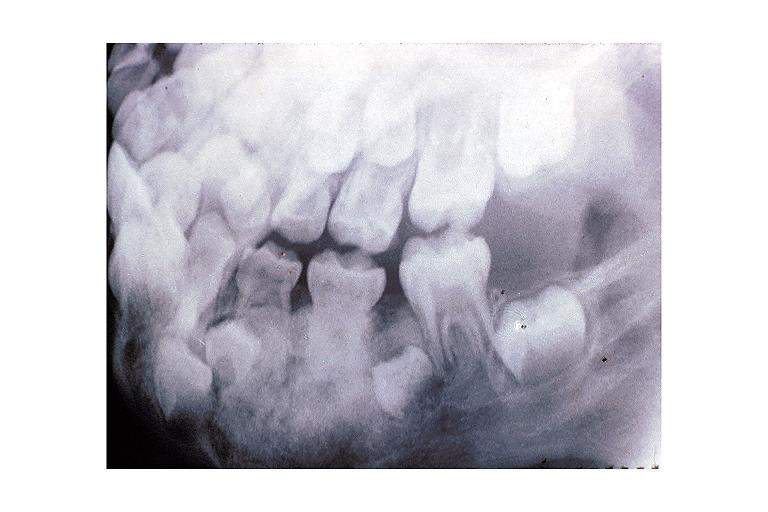s oral present?
Answer the question using a single word or phrase. Yes 